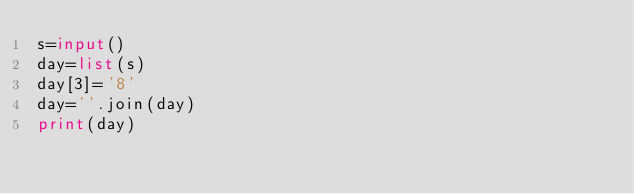<code> <loc_0><loc_0><loc_500><loc_500><_Python_>s=input()
day=list(s)
day[3]='8'
day=''.join(day)
print(day)</code> 